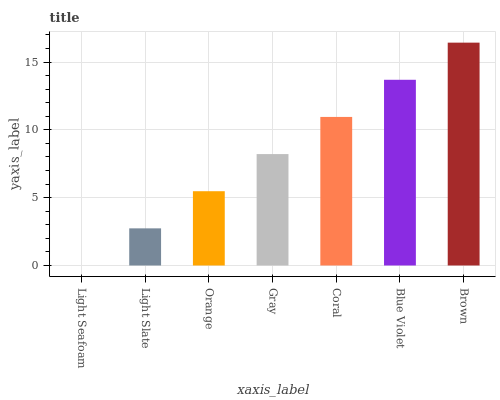Is Light Seafoam the minimum?
Answer yes or no. Yes. Is Brown the maximum?
Answer yes or no. Yes. Is Light Slate the minimum?
Answer yes or no. No. Is Light Slate the maximum?
Answer yes or no. No. Is Light Slate greater than Light Seafoam?
Answer yes or no. Yes. Is Light Seafoam less than Light Slate?
Answer yes or no. Yes. Is Light Seafoam greater than Light Slate?
Answer yes or no. No. Is Light Slate less than Light Seafoam?
Answer yes or no. No. Is Gray the high median?
Answer yes or no. Yes. Is Gray the low median?
Answer yes or no. Yes. Is Coral the high median?
Answer yes or no. No. Is Brown the low median?
Answer yes or no. No. 